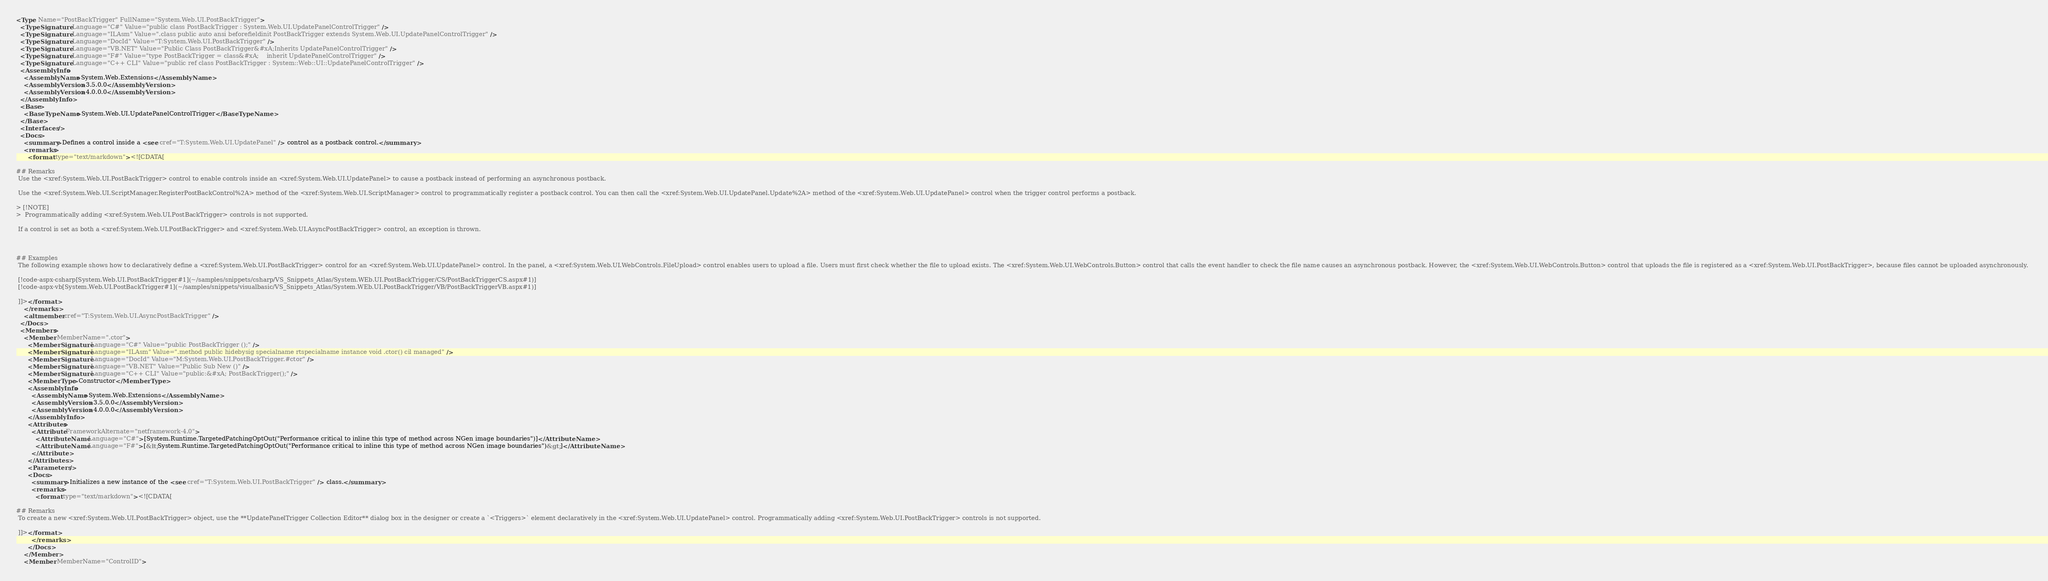Convert code to text. <code><loc_0><loc_0><loc_500><loc_500><_XML_><Type Name="PostBackTrigger" FullName="System.Web.UI.PostBackTrigger">
  <TypeSignature Language="C#" Value="public class PostBackTrigger : System.Web.UI.UpdatePanelControlTrigger" />
  <TypeSignature Language="ILAsm" Value=".class public auto ansi beforefieldinit PostBackTrigger extends System.Web.UI.UpdatePanelControlTrigger" />
  <TypeSignature Language="DocId" Value="T:System.Web.UI.PostBackTrigger" />
  <TypeSignature Language="VB.NET" Value="Public Class PostBackTrigger&#xA;Inherits UpdatePanelControlTrigger" />
  <TypeSignature Language="F#" Value="type PostBackTrigger = class&#xA;    inherit UpdatePanelControlTrigger" />
  <TypeSignature Language="C++ CLI" Value="public ref class PostBackTrigger : System::Web::UI::UpdatePanelControlTrigger" />
  <AssemblyInfo>
    <AssemblyName>System.Web.Extensions</AssemblyName>
    <AssemblyVersion>3.5.0.0</AssemblyVersion>
    <AssemblyVersion>4.0.0.0</AssemblyVersion>
  </AssemblyInfo>
  <Base>
    <BaseTypeName>System.Web.UI.UpdatePanelControlTrigger</BaseTypeName>
  </Base>
  <Interfaces />
  <Docs>
    <summary>Defines a control inside a <see cref="T:System.Web.UI.UpdatePanel" /> control as a postback control.</summary>
    <remarks>
      <format type="text/markdown"><![CDATA[  
  
## Remarks  
 Use the <xref:System.Web.UI.PostBackTrigger> control to enable controls inside an <xref:System.Web.UI.UpdatePanel> to cause a postback instead of performing an asynchronous postback.  
  
 Use the <xref:System.Web.UI.ScriptManager.RegisterPostBackControl%2A> method of the <xref:System.Web.UI.ScriptManager> control to programmatically register a postback control. You can then call the <xref:System.Web.UI.UpdatePanel.Update%2A> method of the <xref:System.Web.UI.UpdatePanel> control when the trigger control performs a postback.  
  
> [!NOTE]
>  Programmatically adding <xref:System.Web.UI.PostBackTrigger> controls is not supported.  
  
 If a control is set as both a <xref:System.Web.UI.PostBackTrigger> and <xref:System.Web.UI.AsyncPostBackTrigger> control, an exception is thrown.  
  
   
  
## Examples  
 The following example shows how to declaratively define a <xref:System.Web.UI.PostBackTrigger> control for an <xref:System.Web.UI.UpdatePanel> control. In the panel, a <xref:System.Web.UI.WebControls.FileUpload> control enables users to upload a file. Users must first check whether the file to upload exists. The <xref:System.Web.UI.WebControls.Button> control that calls the event handler to check the file name causes an asynchronous postback. However, the <xref:System.Web.UI.WebControls.Button> control that uploads the file is registered as a <xref:System.Web.UI.PostBackTrigger>, because files cannot be uploaded asynchronously.  
  
 [!code-aspx-csharp[System.Web.UI.PostBackTrigger#1](~/samples/snippets/csharp/VS_Snippets_Atlas/System.WEb.UI.PostBackTrigger/CS/PostBackTriggerCS.aspx#1)]
 [!code-aspx-vb[System.Web.UI.PostBackTrigger#1](~/samples/snippets/visualbasic/VS_Snippets_Atlas/System.WEb.UI.PostBackTrigger/VB/PostBackTriggerVB.aspx#1)]  
  
 ]]></format>
    </remarks>
    <altmember cref="T:System.Web.UI.AsyncPostBackTrigger" />
  </Docs>
  <Members>
    <Member MemberName=".ctor">
      <MemberSignature Language="C#" Value="public PostBackTrigger ();" />
      <MemberSignature Language="ILAsm" Value=".method public hidebysig specialname rtspecialname instance void .ctor() cil managed" />
      <MemberSignature Language="DocId" Value="M:System.Web.UI.PostBackTrigger.#ctor" />
      <MemberSignature Language="VB.NET" Value="Public Sub New ()" />
      <MemberSignature Language="C++ CLI" Value="public:&#xA; PostBackTrigger();" />
      <MemberType>Constructor</MemberType>
      <AssemblyInfo>
        <AssemblyName>System.Web.Extensions</AssemblyName>
        <AssemblyVersion>3.5.0.0</AssemblyVersion>
        <AssemblyVersion>4.0.0.0</AssemblyVersion>
      </AssemblyInfo>
      <Attributes>
        <Attribute FrameworkAlternate="netframework-4.0">
          <AttributeName Language="C#">[System.Runtime.TargetedPatchingOptOut("Performance critical to inline this type of method across NGen image boundaries")]</AttributeName>
          <AttributeName Language="F#">[&lt;System.Runtime.TargetedPatchingOptOut("Performance critical to inline this type of method across NGen image boundaries")&gt;]</AttributeName>
        </Attribute>
      </Attributes>
      <Parameters />
      <Docs>
        <summary>Initializes a new instance of the <see cref="T:System.Web.UI.PostBackTrigger" /> class.</summary>
        <remarks>
          <format type="text/markdown"><![CDATA[  
  
## Remarks  
 To create a new <xref:System.Web.UI.PostBackTrigger> object, use the **UpdatePanelTrigger Collection Editor** dialog box in the designer or create a `<Triggers>` element declaratively in the <xref:System.Web.UI.UpdatePanel> control. Programmatically adding <xref:System.Web.UI.PostBackTrigger> controls is not supported.  
  
 ]]></format>
        </remarks>
      </Docs>
    </Member>
    <Member MemberName="ControlID"></code> 